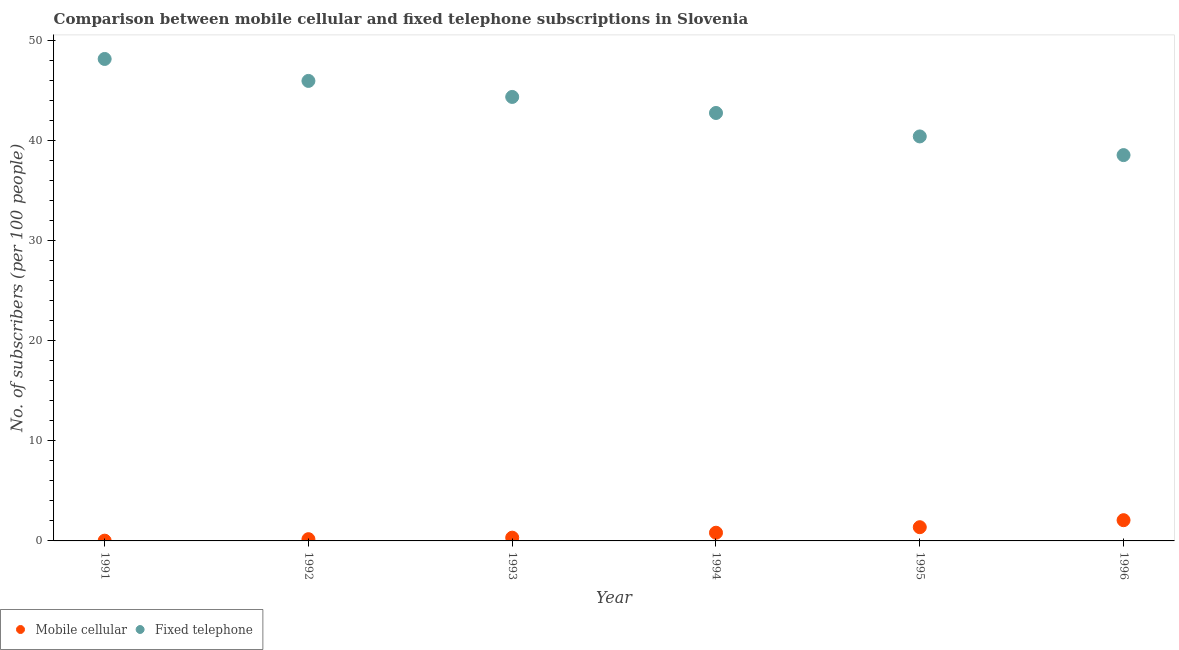Is the number of dotlines equal to the number of legend labels?
Your answer should be very brief. Yes. What is the number of fixed telephone subscribers in 1996?
Your answer should be compact. 38.53. Across all years, what is the maximum number of mobile cellular subscribers?
Give a very brief answer. 2.07. Across all years, what is the minimum number of mobile cellular subscribers?
Your answer should be very brief. 0.03. In which year was the number of mobile cellular subscribers minimum?
Keep it short and to the point. 1991. What is the total number of mobile cellular subscribers in the graph?
Give a very brief answer. 4.79. What is the difference between the number of fixed telephone subscribers in 1993 and that in 1994?
Keep it short and to the point. 1.6. What is the difference between the number of mobile cellular subscribers in 1993 and the number of fixed telephone subscribers in 1996?
Your response must be concise. -38.21. What is the average number of fixed telephone subscribers per year?
Offer a terse response. 43.35. In the year 1995, what is the difference between the number of mobile cellular subscribers and number of fixed telephone subscribers?
Ensure brevity in your answer.  -39.02. What is the ratio of the number of fixed telephone subscribers in 1993 to that in 1994?
Ensure brevity in your answer.  1.04. What is the difference between the highest and the second highest number of fixed telephone subscribers?
Your answer should be compact. 2.19. What is the difference between the highest and the lowest number of fixed telephone subscribers?
Your answer should be very brief. 9.6. In how many years, is the number of mobile cellular subscribers greater than the average number of mobile cellular subscribers taken over all years?
Your answer should be compact. 3. Is the sum of the number of fixed telephone subscribers in 1993 and 1994 greater than the maximum number of mobile cellular subscribers across all years?
Make the answer very short. Yes. How many years are there in the graph?
Provide a succinct answer. 6. Does the graph contain any zero values?
Keep it short and to the point. No. Where does the legend appear in the graph?
Provide a short and direct response. Bottom left. How are the legend labels stacked?
Give a very brief answer. Horizontal. What is the title of the graph?
Offer a terse response. Comparison between mobile cellular and fixed telephone subscriptions in Slovenia. What is the label or title of the X-axis?
Give a very brief answer. Year. What is the label or title of the Y-axis?
Offer a terse response. No. of subscribers (per 100 people). What is the No. of subscribers (per 100 people) in Mobile cellular in 1991?
Your response must be concise. 0.03. What is the No. of subscribers (per 100 people) of Fixed telephone in 1991?
Keep it short and to the point. 48.13. What is the No. of subscribers (per 100 people) of Mobile cellular in 1992?
Provide a short and direct response. 0.17. What is the No. of subscribers (per 100 people) in Fixed telephone in 1992?
Provide a succinct answer. 45.94. What is the No. of subscribers (per 100 people) of Mobile cellular in 1993?
Keep it short and to the point. 0.33. What is the No. of subscribers (per 100 people) in Fixed telephone in 1993?
Offer a very short reply. 44.34. What is the No. of subscribers (per 100 people) in Mobile cellular in 1994?
Ensure brevity in your answer.  0.82. What is the No. of subscribers (per 100 people) of Fixed telephone in 1994?
Give a very brief answer. 42.74. What is the No. of subscribers (per 100 people) of Mobile cellular in 1995?
Your response must be concise. 1.37. What is the No. of subscribers (per 100 people) of Fixed telephone in 1995?
Ensure brevity in your answer.  40.4. What is the No. of subscribers (per 100 people) of Mobile cellular in 1996?
Your answer should be very brief. 2.07. What is the No. of subscribers (per 100 people) of Fixed telephone in 1996?
Provide a short and direct response. 38.53. Across all years, what is the maximum No. of subscribers (per 100 people) in Mobile cellular?
Offer a terse response. 2.07. Across all years, what is the maximum No. of subscribers (per 100 people) in Fixed telephone?
Give a very brief answer. 48.13. Across all years, what is the minimum No. of subscribers (per 100 people) in Mobile cellular?
Offer a terse response. 0.03. Across all years, what is the minimum No. of subscribers (per 100 people) in Fixed telephone?
Keep it short and to the point. 38.53. What is the total No. of subscribers (per 100 people) in Mobile cellular in the graph?
Offer a very short reply. 4.79. What is the total No. of subscribers (per 100 people) of Fixed telephone in the graph?
Your response must be concise. 260.07. What is the difference between the No. of subscribers (per 100 people) in Mobile cellular in 1991 and that in 1992?
Offer a terse response. -0.15. What is the difference between the No. of subscribers (per 100 people) of Fixed telephone in 1991 and that in 1992?
Make the answer very short. 2.19. What is the difference between the No. of subscribers (per 100 people) in Mobile cellular in 1991 and that in 1993?
Provide a succinct answer. -0.3. What is the difference between the No. of subscribers (per 100 people) of Fixed telephone in 1991 and that in 1993?
Make the answer very short. 3.79. What is the difference between the No. of subscribers (per 100 people) in Mobile cellular in 1991 and that in 1994?
Provide a short and direct response. -0.79. What is the difference between the No. of subscribers (per 100 people) of Fixed telephone in 1991 and that in 1994?
Provide a succinct answer. 5.39. What is the difference between the No. of subscribers (per 100 people) of Mobile cellular in 1991 and that in 1995?
Your response must be concise. -1.34. What is the difference between the No. of subscribers (per 100 people) of Fixed telephone in 1991 and that in 1995?
Offer a terse response. 7.74. What is the difference between the No. of subscribers (per 100 people) in Mobile cellular in 1991 and that in 1996?
Offer a terse response. -2.04. What is the difference between the No. of subscribers (per 100 people) in Fixed telephone in 1991 and that in 1996?
Provide a short and direct response. 9.6. What is the difference between the No. of subscribers (per 100 people) in Mobile cellular in 1992 and that in 1993?
Keep it short and to the point. -0.15. What is the difference between the No. of subscribers (per 100 people) of Fixed telephone in 1992 and that in 1993?
Make the answer very short. 1.6. What is the difference between the No. of subscribers (per 100 people) in Mobile cellular in 1992 and that in 1994?
Offer a very short reply. -0.64. What is the difference between the No. of subscribers (per 100 people) in Fixed telephone in 1992 and that in 1994?
Provide a succinct answer. 3.2. What is the difference between the No. of subscribers (per 100 people) in Mobile cellular in 1992 and that in 1995?
Give a very brief answer. -1.2. What is the difference between the No. of subscribers (per 100 people) of Fixed telephone in 1992 and that in 1995?
Offer a terse response. 5.54. What is the difference between the No. of subscribers (per 100 people) in Mobile cellular in 1992 and that in 1996?
Your answer should be compact. -1.9. What is the difference between the No. of subscribers (per 100 people) of Fixed telephone in 1992 and that in 1996?
Give a very brief answer. 7.41. What is the difference between the No. of subscribers (per 100 people) of Mobile cellular in 1993 and that in 1994?
Make the answer very short. -0.49. What is the difference between the No. of subscribers (per 100 people) of Fixed telephone in 1993 and that in 1994?
Keep it short and to the point. 1.6. What is the difference between the No. of subscribers (per 100 people) of Mobile cellular in 1993 and that in 1995?
Give a very brief answer. -1.05. What is the difference between the No. of subscribers (per 100 people) of Fixed telephone in 1993 and that in 1995?
Keep it short and to the point. 3.94. What is the difference between the No. of subscribers (per 100 people) of Mobile cellular in 1993 and that in 1996?
Provide a short and direct response. -1.75. What is the difference between the No. of subscribers (per 100 people) in Fixed telephone in 1993 and that in 1996?
Offer a terse response. 5.81. What is the difference between the No. of subscribers (per 100 people) of Mobile cellular in 1994 and that in 1995?
Provide a short and direct response. -0.55. What is the difference between the No. of subscribers (per 100 people) of Fixed telephone in 1994 and that in 1995?
Your response must be concise. 2.34. What is the difference between the No. of subscribers (per 100 people) of Mobile cellular in 1994 and that in 1996?
Your response must be concise. -1.25. What is the difference between the No. of subscribers (per 100 people) of Fixed telephone in 1994 and that in 1996?
Give a very brief answer. 4.21. What is the difference between the No. of subscribers (per 100 people) in Mobile cellular in 1995 and that in 1996?
Keep it short and to the point. -0.7. What is the difference between the No. of subscribers (per 100 people) of Fixed telephone in 1995 and that in 1996?
Your response must be concise. 1.86. What is the difference between the No. of subscribers (per 100 people) in Mobile cellular in 1991 and the No. of subscribers (per 100 people) in Fixed telephone in 1992?
Keep it short and to the point. -45.91. What is the difference between the No. of subscribers (per 100 people) in Mobile cellular in 1991 and the No. of subscribers (per 100 people) in Fixed telephone in 1993?
Keep it short and to the point. -44.31. What is the difference between the No. of subscribers (per 100 people) of Mobile cellular in 1991 and the No. of subscribers (per 100 people) of Fixed telephone in 1994?
Your answer should be compact. -42.71. What is the difference between the No. of subscribers (per 100 people) of Mobile cellular in 1991 and the No. of subscribers (per 100 people) of Fixed telephone in 1995?
Your response must be concise. -40.37. What is the difference between the No. of subscribers (per 100 people) in Mobile cellular in 1991 and the No. of subscribers (per 100 people) in Fixed telephone in 1996?
Your answer should be very brief. -38.5. What is the difference between the No. of subscribers (per 100 people) of Mobile cellular in 1992 and the No. of subscribers (per 100 people) of Fixed telephone in 1993?
Your answer should be compact. -44.16. What is the difference between the No. of subscribers (per 100 people) of Mobile cellular in 1992 and the No. of subscribers (per 100 people) of Fixed telephone in 1994?
Provide a succinct answer. -42.56. What is the difference between the No. of subscribers (per 100 people) in Mobile cellular in 1992 and the No. of subscribers (per 100 people) in Fixed telephone in 1995?
Offer a very short reply. -40.22. What is the difference between the No. of subscribers (per 100 people) in Mobile cellular in 1992 and the No. of subscribers (per 100 people) in Fixed telephone in 1996?
Make the answer very short. -38.36. What is the difference between the No. of subscribers (per 100 people) in Mobile cellular in 1993 and the No. of subscribers (per 100 people) in Fixed telephone in 1994?
Your answer should be compact. -42.41. What is the difference between the No. of subscribers (per 100 people) in Mobile cellular in 1993 and the No. of subscribers (per 100 people) in Fixed telephone in 1995?
Your response must be concise. -40.07. What is the difference between the No. of subscribers (per 100 people) in Mobile cellular in 1993 and the No. of subscribers (per 100 people) in Fixed telephone in 1996?
Your answer should be very brief. -38.21. What is the difference between the No. of subscribers (per 100 people) in Mobile cellular in 1994 and the No. of subscribers (per 100 people) in Fixed telephone in 1995?
Ensure brevity in your answer.  -39.58. What is the difference between the No. of subscribers (per 100 people) in Mobile cellular in 1994 and the No. of subscribers (per 100 people) in Fixed telephone in 1996?
Your answer should be compact. -37.71. What is the difference between the No. of subscribers (per 100 people) in Mobile cellular in 1995 and the No. of subscribers (per 100 people) in Fixed telephone in 1996?
Offer a very short reply. -37.16. What is the average No. of subscribers (per 100 people) of Mobile cellular per year?
Make the answer very short. 0.8. What is the average No. of subscribers (per 100 people) in Fixed telephone per year?
Make the answer very short. 43.35. In the year 1991, what is the difference between the No. of subscribers (per 100 people) of Mobile cellular and No. of subscribers (per 100 people) of Fixed telephone?
Provide a succinct answer. -48.11. In the year 1992, what is the difference between the No. of subscribers (per 100 people) in Mobile cellular and No. of subscribers (per 100 people) in Fixed telephone?
Your answer should be very brief. -45.76. In the year 1993, what is the difference between the No. of subscribers (per 100 people) of Mobile cellular and No. of subscribers (per 100 people) of Fixed telephone?
Keep it short and to the point. -44.01. In the year 1994, what is the difference between the No. of subscribers (per 100 people) in Mobile cellular and No. of subscribers (per 100 people) in Fixed telephone?
Your response must be concise. -41.92. In the year 1995, what is the difference between the No. of subscribers (per 100 people) of Mobile cellular and No. of subscribers (per 100 people) of Fixed telephone?
Provide a succinct answer. -39.02. In the year 1996, what is the difference between the No. of subscribers (per 100 people) in Mobile cellular and No. of subscribers (per 100 people) in Fixed telephone?
Make the answer very short. -36.46. What is the ratio of the No. of subscribers (per 100 people) in Mobile cellular in 1991 to that in 1992?
Provide a short and direct response. 0.15. What is the ratio of the No. of subscribers (per 100 people) in Fixed telephone in 1991 to that in 1992?
Give a very brief answer. 1.05. What is the ratio of the No. of subscribers (per 100 people) in Mobile cellular in 1991 to that in 1993?
Offer a very short reply. 0.08. What is the ratio of the No. of subscribers (per 100 people) of Fixed telephone in 1991 to that in 1993?
Give a very brief answer. 1.09. What is the ratio of the No. of subscribers (per 100 people) in Mobile cellular in 1991 to that in 1994?
Offer a terse response. 0.03. What is the ratio of the No. of subscribers (per 100 people) of Fixed telephone in 1991 to that in 1994?
Give a very brief answer. 1.13. What is the ratio of the No. of subscribers (per 100 people) in Mobile cellular in 1991 to that in 1995?
Ensure brevity in your answer.  0.02. What is the ratio of the No. of subscribers (per 100 people) of Fixed telephone in 1991 to that in 1995?
Make the answer very short. 1.19. What is the ratio of the No. of subscribers (per 100 people) in Mobile cellular in 1991 to that in 1996?
Give a very brief answer. 0.01. What is the ratio of the No. of subscribers (per 100 people) in Fixed telephone in 1991 to that in 1996?
Give a very brief answer. 1.25. What is the ratio of the No. of subscribers (per 100 people) in Mobile cellular in 1992 to that in 1993?
Make the answer very short. 0.54. What is the ratio of the No. of subscribers (per 100 people) of Fixed telephone in 1992 to that in 1993?
Your answer should be very brief. 1.04. What is the ratio of the No. of subscribers (per 100 people) in Mobile cellular in 1992 to that in 1994?
Ensure brevity in your answer.  0.21. What is the ratio of the No. of subscribers (per 100 people) in Fixed telephone in 1992 to that in 1994?
Your answer should be very brief. 1.07. What is the ratio of the No. of subscribers (per 100 people) in Mobile cellular in 1992 to that in 1995?
Your response must be concise. 0.13. What is the ratio of the No. of subscribers (per 100 people) in Fixed telephone in 1992 to that in 1995?
Provide a short and direct response. 1.14. What is the ratio of the No. of subscribers (per 100 people) of Mobile cellular in 1992 to that in 1996?
Your answer should be compact. 0.08. What is the ratio of the No. of subscribers (per 100 people) in Fixed telephone in 1992 to that in 1996?
Your answer should be very brief. 1.19. What is the ratio of the No. of subscribers (per 100 people) in Mobile cellular in 1993 to that in 1994?
Your answer should be compact. 0.4. What is the ratio of the No. of subscribers (per 100 people) in Fixed telephone in 1993 to that in 1994?
Ensure brevity in your answer.  1.04. What is the ratio of the No. of subscribers (per 100 people) of Mobile cellular in 1993 to that in 1995?
Give a very brief answer. 0.24. What is the ratio of the No. of subscribers (per 100 people) in Fixed telephone in 1993 to that in 1995?
Your answer should be compact. 1.1. What is the ratio of the No. of subscribers (per 100 people) of Mobile cellular in 1993 to that in 1996?
Make the answer very short. 0.16. What is the ratio of the No. of subscribers (per 100 people) in Fixed telephone in 1993 to that in 1996?
Your answer should be compact. 1.15. What is the ratio of the No. of subscribers (per 100 people) of Mobile cellular in 1994 to that in 1995?
Provide a short and direct response. 0.6. What is the ratio of the No. of subscribers (per 100 people) in Fixed telephone in 1994 to that in 1995?
Your answer should be very brief. 1.06. What is the ratio of the No. of subscribers (per 100 people) in Mobile cellular in 1994 to that in 1996?
Ensure brevity in your answer.  0.4. What is the ratio of the No. of subscribers (per 100 people) of Fixed telephone in 1994 to that in 1996?
Your answer should be compact. 1.11. What is the ratio of the No. of subscribers (per 100 people) of Mobile cellular in 1995 to that in 1996?
Offer a terse response. 0.66. What is the ratio of the No. of subscribers (per 100 people) of Fixed telephone in 1995 to that in 1996?
Offer a terse response. 1.05. What is the difference between the highest and the second highest No. of subscribers (per 100 people) in Mobile cellular?
Offer a terse response. 0.7. What is the difference between the highest and the second highest No. of subscribers (per 100 people) of Fixed telephone?
Offer a terse response. 2.19. What is the difference between the highest and the lowest No. of subscribers (per 100 people) of Mobile cellular?
Your answer should be very brief. 2.04. What is the difference between the highest and the lowest No. of subscribers (per 100 people) in Fixed telephone?
Provide a succinct answer. 9.6. 